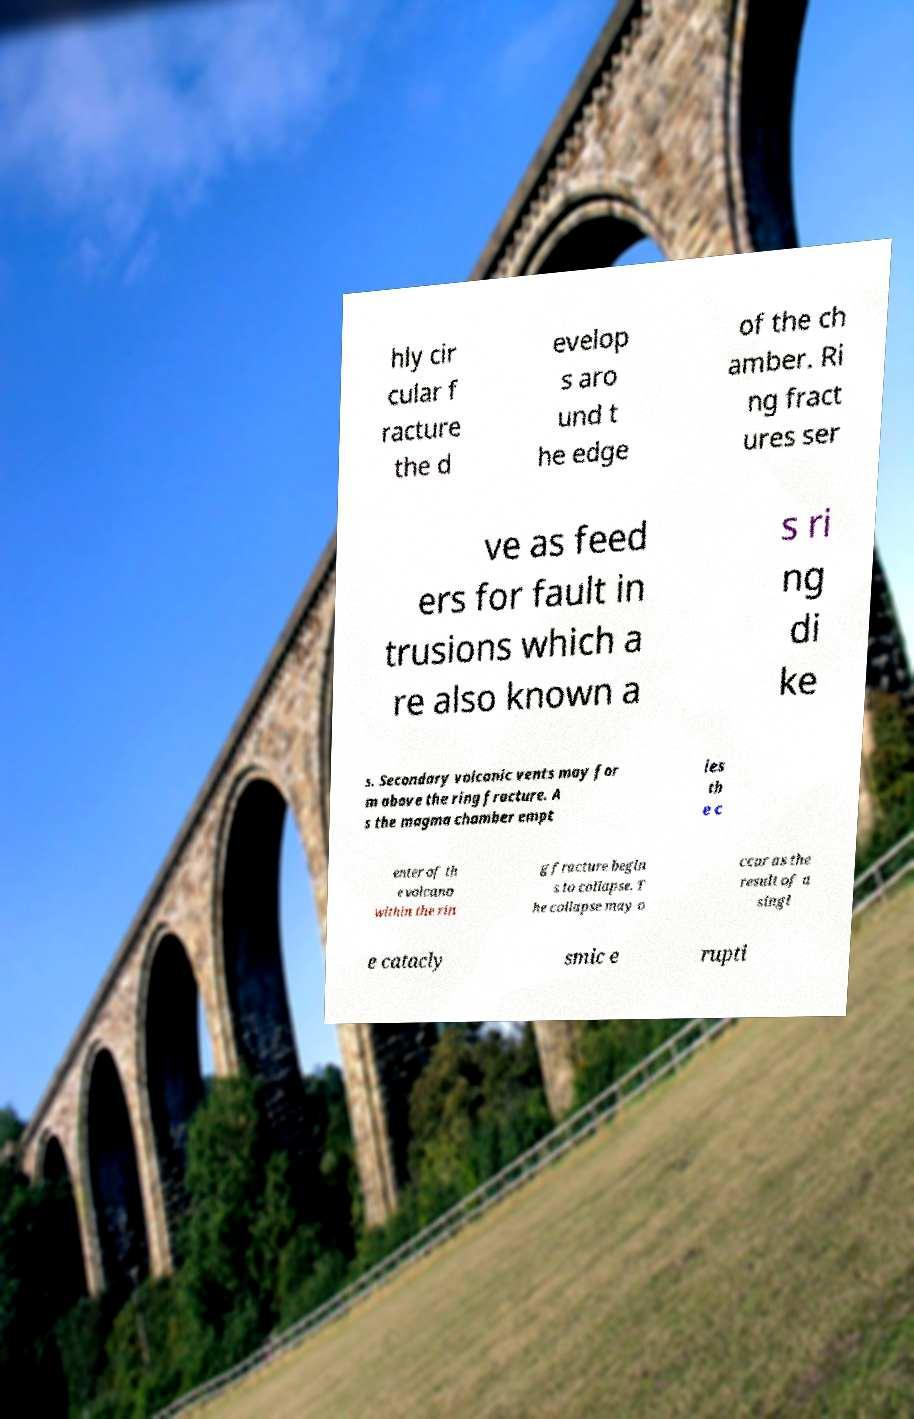Could you extract and type out the text from this image? hly cir cular f racture the d evelop s aro und t he edge of the ch amber. Ri ng fract ures ser ve as feed ers for fault in trusions which a re also known a s ri ng di ke s. Secondary volcanic vents may for m above the ring fracture. A s the magma chamber empt ies th e c enter of th e volcano within the rin g fracture begin s to collapse. T he collapse may o ccur as the result of a singl e catacly smic e rupti 